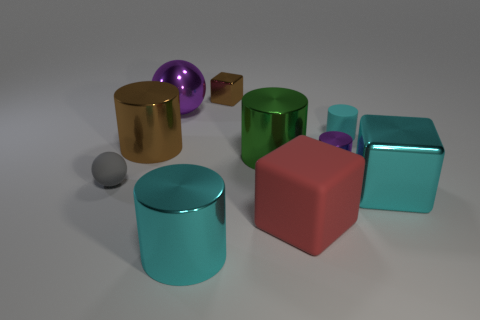Subtract all big cyan metallic blocks. How many blocks are left? 2 Subtract all brown cylinders. How many cylinders are left? 4 Subtract all red spheres. How many cyan cylinders are left? 2 Subtract 2 blocks. How many blocks are left? 1 Subtract 1 brown cylinders. How many objects are left? 9 Subtract all blocks. How many objects are left? 7 Subtract all green blocks. Subtract all brown cylinders. How many blocks are left? 3 Subtract all red matte cubes. Subtract all tiny rubber cylinders. How many objects are left? 8 Add 4 matte balls. How many matte balls are left? 5 Add 9 small metallic cylinders. How many small metallic cylinders exist? 10 